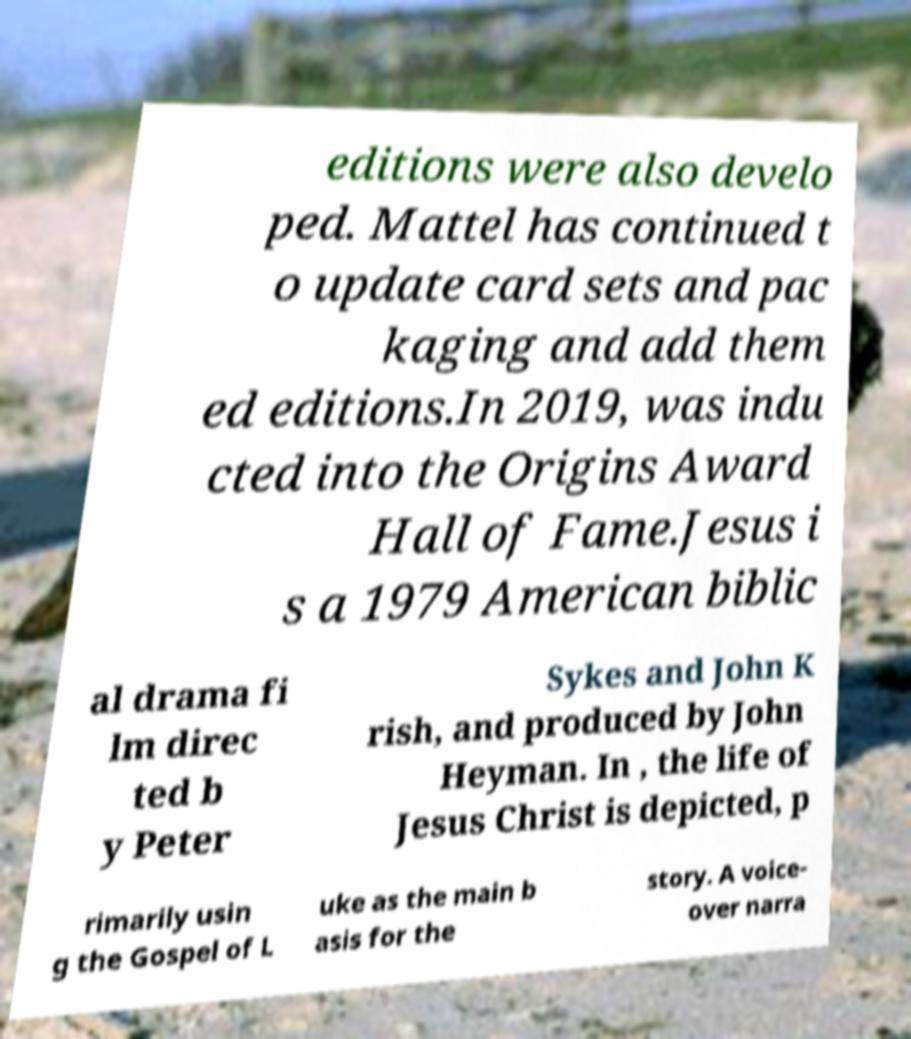Can you accurately transcribe the text from the provided image for me? editions were also develo ped. Mattel has continued t o update card sets and pac kaging and add them ed editions.In 2019, was indu cted into the Origins Award Hall of Fame.Jesus i s a 1979 American biblic al drama fi lm direc ted b y Peter Sykes and John K rish, and produced by John Heyman. In , the life of Jesus Christ is depicted, p rimarily usin g the Gospel of L uke as the main b asis for the story. A voice- over narra 